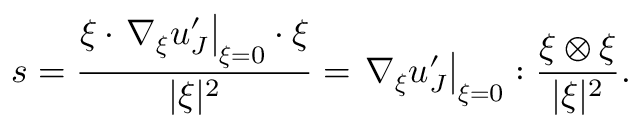Convert formula to latex. <formula><loc_0><loc_0><loc_500><loc_500>s = \frac { \xi \cdot \nabla _ { \xi } u _ { J } ^ { \prime } \right | _ { \xi = 0 } \cdot \xi } { | \xi | ^ { 2 } } = \nabla _ { \xi } u _ { J } ^ { \prime } \right | _ { \xi = 0 } \colon \frac { \xi \otimes \xi } { | \xi | ^ { 2 } } .</formula> 